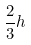<formula> <loc_0><loc_0><loc_500><loc_500>\frac { 2 } { 3 } h</formula> 